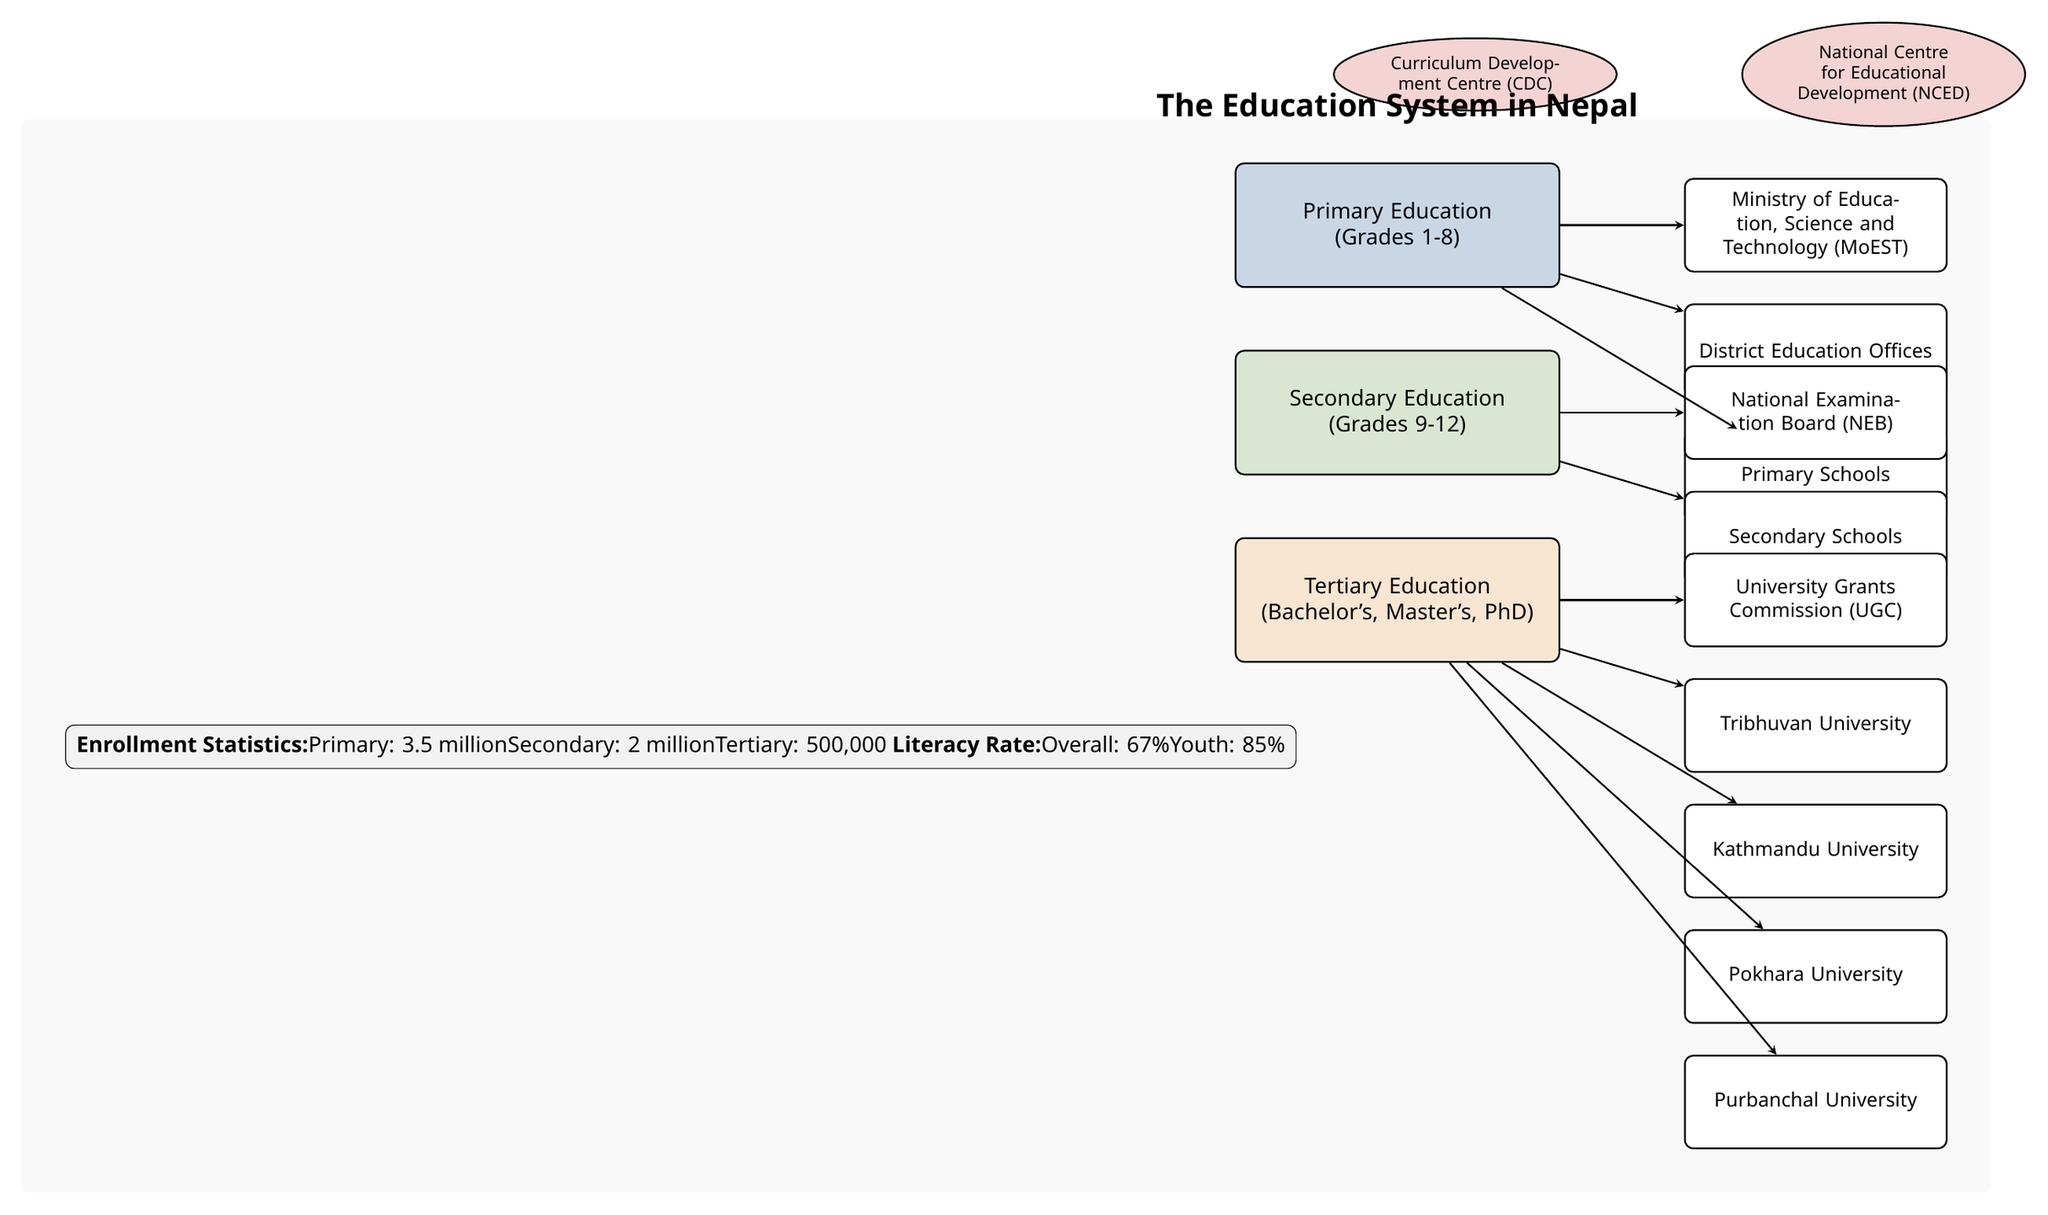What are the three layers of the education system in Nepal? The diagram consists of three layers representing the education system: Primary Education, Secondary Education, and Tertiary Education. Each layer is labeled clearly, with the Primary layer on top, followed by Secondary, and then Tertiary at the bottom.
Answer: Primary Education, Secondary Education, Tertiary Education How many entities are shown under Tertiary Education? Under the Tertiary Education layer, there are five entities listed: University Grants Commission (UGC), Tribhuvan University, Kathmandu University, Pokhara University, and Purbanchal University. Counting these entities gives a total of five.
Answer: 5 What is the enrollment statistic for Secondary Education? The diagram indicates that the enrollment statistic for Secondary Education is 2 million students. This specific statistic is detailed in the statistics box contained within the diagram.
Answer: 2 million Which board is responsible for Secondary Education? The National Examination Board (NEB) is responsible for overseeing Secondary Education in Nepal, as indicated in the diagram positioned next to the Secondary Education layer.
Answer: National Examination Board (NEB) What percentage represents the overall literacy rate in Nepal according to the diagram? According to the statistics box in the diagram, the overall literacy rate in Nepal is indicated to be 67%. This statistic is explicitly stated in the enrollment statistics section.
Answer: 67% What is the relationship between Primary Education and the Ministry of Education, Science and Technology? The diagram illustrates a direct relationship between Primary Education and the Ministry of Education, Science and Technology, with an arrow pointing from the Primary Education layer to the Ministry entity, indicating that the ministry oversees Primary Education.
Answer: Oversight Which educational institution is shown at the top of Secondary Education entities? The National Examination Board (NEB) is the topmost entity listed under the Secondary Education layer in the diagram. It is positioned directly above the Secondary Schools entity with an arrow indicating their connection.
Answer: National Examination Board (NEB) How many students are enrolled in Tertiary Education? The enrollment statistic for Tertiary Education, as stated in the statistics box of the diagram, is 500,000. This is clearly labeled under the enrollment statistics section.
Answer: 500,000 Which organization is shown to oversee Tertiary Education in Nepal? The University Grants Commission (UGC) is the organization responsible for overseeing Tertiary Education in Nepal, as depicted in the diagram next to the Tertiary Education layer.
Answer: University Grants Commission (UGC) 